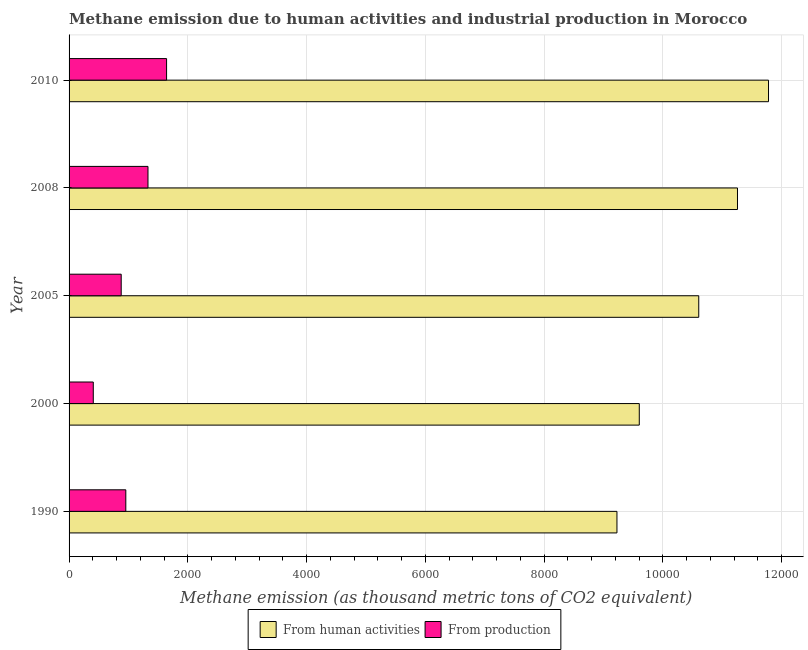How many different coloured bars are there?
Provide a succinct answer. 2. Are the number of bars on each tick of the Y-axis equal?
Ensure brevity in your answer.  Yes. What is the label of the 5th group of bars from the top?
Provide a succinct answer. 1990. In how many cases, is the number of bars for a given year not equal to the number of legend labels?
Ensure brevity in your answer.  0. What is the amount of emissions generated from industries in 2008?
Your answer should be very brief. 1328.7. Across all years, what is the maximum amount of emissions from human activities?
Your answer should be compact. 1.18e+04. Across all years, what is the minimum amount of emissions generated from industries?
Ensure brevity in your answer.  407.6. In which year was the amount of emissions generated from industries minimum?
Offer a very short reply. 2000. What is the total amount of emissions generated from industries in the graph?
Your answer should be compact. 5211.3. What is the difference between the amount of emissions generated from industries in 1990 and that in 2005?
Offer a terse response. 77.7. What is the difference between the amount of emissions from human activities in 2005 and the amount of emissions generated from industries in 2008?
Your answer should be compact. 9274.2. What is the average amount of emissions from human activities per year?
Keep it short and to the point. 1.05e+04. In the year 2008, what is the difference between the amount of emissions from human activities and amount of emissions generated from industries?
Provide a succinct answer. 9926.4. What is the ratio of the amount of emissions from human activities in 2005 to that in 2010?
Make the answer very short. 0.9. What is the difference between the highest and the second highest amount of emissions generated from industries?
Offer a terse response. 313.2. What is the difference between the highest and the lowest amount of emissions generated from industries?
Offer a terse response. 1234.3. What does the 1st bar from the top in 2010 represents?
Your answer should be very brief. From production. What does the 2nd bar from the bottom in 2008 represents?
Your response must be concise. From production. Are all the bars in the graph horizontal?
Offer a very short reply. Yes. Does the graph contain grids?
Give a very brief answer. Yes. Where does the legend appear in the graph?
Make the answer very short. Bottom center. How many legend labels are there?
Keep it short and to the point. 2. How are the legend labels stacked?
Your answer should be very brief. Horizontal. What is the title of the graph?
Your response must be concise. Methane emission due to human activities and industrial production in Morocco. Does "Total Population" appear as one of the legend labels in the graph?
Give a very brief answer. No. What is the label or title of the X-axis?
Your response must be concise. Methane emission (as thousand metric tons of CO2 equivalent). What is the Methane emission (as thousand metric tons of CO2 equivalent) in From human activities in 1990?
Offer a terse response. 9225.5. What is the Methane emission (as thousand metric tons of CO2 equivalent) of From production in 1990?
Your response must be concise. 955.4. What is the Methane emission (as thousand metric tons of CO2 equivalent) in From human activities in 2000?
Ensure brevity in your answer.  9601.5. What is the Methane emission (as thousand metric tons of CO2 equivalent) of From production in 2000?
Offer a very short reply. 407.6. What is the Methane emission (as thousand metric tons of CO2 equivalent) in From human activities in 2005?
Offer a terse response. 1.06e+04. What is the Methane emission (as thousand metric tons of CO2 equivalent) of From production in 2005?
Offer a very short reply. 877.7. What is the Methane emission (as thousand metric tons of CO2 equivalent) of From human activities in 2008?
Your response must be concise. 1.13e+04. What is the Methane emission (as thousand metric tons of CO2 equivalent) in From production in 2008?
Offer a terse response. 1328.7. What is the Methane emission (as thousand metric tons of CO2 equivalent) of From human activities in 2010?
Provide a succinct answer. 1.18e+04. What is the Methane emission (as thousand metric tons of CO2 equivalent) of From production in 2010?
Offer a very short reply. 1641.9. Across all years, what is the maximum Methane emission (as thousand metric tons of CO2 equivalent) in From human activities?
Ensure brevity in your answer.  1.18e+04. Across all years, what is the maximum Methane emission (as thousand metric tons of CO2 equivalent) of From production?
Ensure brevity in your answer.  1641.9. Across all years, what is the minimum Methane emission (as thousand metric tons of CO2 equivalent) of From human activities?
Provide a succinct answer. 9225.5. Across all years, what is the minimum Methane emission (as thousand metric tons of CO2 equivalent) in From production?
Give a very brief answer. 407.6. What is the total Methane emission (as thousand metric tons of CO2 equivalent) of From human activities in the graph?
Offer a very short reply. 5.25e+04. What is the total Methane emission (as thousand metric tons of CO2 equivalent) in From production in the graph?
Provide a short and direct response. 5211.3. What is the difference between the Methane emission (as thousand metric tons of CO2 equivalent) in From human activities in 1990 and that in 2000?
Ensure brevity in your answer.  -376. What is the difference between the Methane emission (as thousand metric tons of CO2 equivalent) of From production in 1990 and that in 2000?
Your answer should be compact. 547.8. What is the difference between the Methane emission (as thousand metric tons of CO2 equivalent) in From human activities in 1990 and that in 2005?
Keep it short and to the point. -1377.4. What is the difference between the Methane emission (as thousand metric tons of CO2 equivalent) of From production in 1990 and that in 2005?
Give a very brief answer. 77.7. What is the difference between the Methane emission (as thousand metric tons of CO2 equivalent) in From human activities in 1990 and that in 2008?
Your answer should be compact. -2029.6. What is the difference between the Methane emission (as thousand metric tons of CO2 equivalent) in From production in 1990 and that in 2008?
Keep it short and to the point. -373.3. What is the difference between the Methane emission (as thousand metric tons of CO2 equivalent) of From human activities in 1990 and that in 2010?
Keep it short and to the point. -2552.1. What is the difference between the Methane emission (as thousand metric tons of CO2 equivalent) in From production in 1990 and that in 2010?
Your answer should be very brief. -686.5. What is the difference between the Methane emission (as thousand metric tons of CO2 equivalent) in From human activities in 2000 and that in 2005?
Ensure brevity in your answer.  -1001.4. What is the difference between the Methane emission (as thousand metric tons of CO2 equivalent) in From production in 2000 and that in 2005?
Give a very brief answer. -470.1. What is the difference between the Methane emission (as thousand metric tons of CO2 equivalent) in From human activities in 2000 and that in 2008?
Your response must be concise. -1653.6. What is the difference between the Methane emission (as thousand metric tons of CO2 equivalent) in From production in 2000 and that in 2008?
Your answer should be compact. -921.1. What is the difference between the Methane emission (as thousand metric tons of CO2 equivalent) of From human activities in 2000 and that in 2010?
Give a very brief answer. -2176.1. What is the difference between the Methane emission (as thousand metric tons of CO2 equivalent) of From production in 2000 and that in 2010?
Give a very brief answer. -1234.3. What is the difference between the Methane emission (as thousand metric tons of CO2 equivalent) of From human activities in 2005 and that in 2008?
Your answer should be very brief. -652.2. What is the difference between the Methane emission (as thousand metric tons of CO2 equivalent) of From production in 2005 and that in 2008?
Keep it short and to the point. -451. What is the difference between the Methane emission (as thousand metric tons of CO2 equivalent) of From human activities in 2005 and that in 2010?
Offer a terse response. -1174.7. What is the difference between the Methane emission (as thousand metric tons of CO2 equivalent) of From production in 2005 and that in 2010?
Provide a succinct answer. -764.2. What is the difference between the Methane emission (as thousand metric tons of CO2 equivalent) of From human activities in 2008 and that in 2010?
Offer a very short reply. -522.5. What is the difference between the Methane emission (as thousand metric tons of CO2 equivalent) of From production in 2008 and that in 2010?
Ensure brevity in your answer.  -313.2. What is the difference between the Methane emission (as thousand metric tons of CO2 equivalent) of From human activities in 1990 and the Methane emission (as thousand metric tons of CO2 equivalent) of From production in 2000?
Ensure brevity in your answer.  8817.9. What is the difference between the Methane emission (as thousand metric tons of CO2 equivalent) in From human activities in 1990 and the Methane emission (as thousand metric tons of CO2 equivalent) in From production in 2005?
Your answer should be compact. 8347.8. What is the difference between the Methane emission (as thousand metric tons of CO2 equivalent) of From human activities in 1990 and the Methane emission (as thousand metric tons of CO2 equivalent) of From production in 2008?
Your response must be concise. 7896.8. What is the difference between the Methane emission (as thousand metric tons of CO2 equivalent) of From human activities in 1990 and the Methane emission (as thousand metric tons of CO2 equivalent) of From production in 2010?
Your response must be concise. 7583.6. What is the difference between the Methane emission (as thousand metric tons of CO2 equivalent) of From human activities in 2000 and the Methane emission (as thousand metric tons of CO2 equivalent) of From production in 2005?
Give a very brief answer. 8723.8. What is the difference between the Methane emission (as thousand metric tons of CO2 equivalent) in From human activities in 2000 and the Methane emission (as thousand metric tons of CO2 equivalent) in From production in 2008?
Provide a short and direct response. 8272.8. What is the difference between the Methane emission (as thousand metric tons of CO2 equivalent) in From human activities in 2000 and the Methane emission (as thousand metric tons of CO2 equivalent) in From production in 2010?
Give a very brief answer. 7959.6. What is the difference between the Methane emission (as thousand metric tons of CO2 equivalent) in From human activities in 2005 and the Methane emission (as thousand metric tons of CO2 equivalent) in From production in 2008?
Keep it short and to the point. 9274.2. What is the difference between the Methane emission (as thousand metric tons of CO2 equivalent) of From human activities in 2005 and the Methane emission (as thousand metric tons of CO2 equivalent) of From production in 2010?
Your answer should be very brief. 8961. What is the difference between the Methane emission (as thousand metric tons of CO2 equivalent) in From human activities in 2008 and the Methane emission (as thousand metric tons of CO2 equivalent) in From production in 2010?
Your response must be concise. 9613.2. What is the average Methane emission (as thousand metric tons of CO2 equivalent) in From human activities per year?
Provide a succinct answer. 1.05e+04. What is the average Methane emission (as thousand metric tons of CO2 equivalent) in From production per year?
Make the answer very short. 1042.26. In the year 1990, what is the difference between the Methane emission (as thousand metric tons of CO2 equivalent) in From human activities and Methane emission (as thousand metric tons of CO2 equivalent) in From production?
Make the answer very short. 8270.1. In the year 2000, what is the difference between the Methane emission (as thousand metric tons of CO2 equivalent) in From human activities and Methane emission (as thousand metric tons of CO2 equivalent) in From production?
Ensure brevity in your answer.  9193.9. In the year 2005, what is the difference between the Methane emission (as thousand metric tons of CO2 equivalent) in From human activities and Methane emission (as thousand metric tons of CO2 equivalent) in From production?
Keep it short and to the point. 9725.2. In the year 2008, what is the difference between the Methane emission (as thousand metric tons of CO2 equivalent) in From human activities and Methane emission (as thousand metric tons of CO2 equivalent) in From production?
Give a very brief answer. 9926.4. In the year 2010, what is the difference between the Methane emission (as thousand metric tons of CO2 equivalent) of From human activities and Methane emission (as thousand metric tons of CO2 equivalent) of From production?
Provide a succinct answer. 1.01e+04. What is the ratio of the Methane emission (as thousand metric tons of CO2 equivalent) in From human activities in 1990 to that in 2000?
Your response must be concise. 0.96. What is the ratio of the Methane emission (as thousand metric tons of CO2 equivalent) of From production in 1990 to that in 2000?
Your answer should be compact. 2.34. What is the ratio of the Methane emission (as thousand metric tons of CO2 equivalent) in From human activities in 1990 to that in 2005?
Offer a terse response. 0.87. What is the ratio of the Methane emission (as thousand metric tons of CO2 equivalent) of From production in 1990 to that in 2005?
Offer a very short reply. 1.09. What is the ratio of the Methane emission (as thousand metric tons of CO2 equivalent) in From human activities in 1990 to that in 2008?
Your answer should be compact. 0.82. What is the ratio of the Methane emission (as thousand metric tons of CO2 equivalent) of From production in 1990 to that in 2008?
Offer a very short reply. 0.72. What is the ratio of the Methane emission (as thousand metric tons of CO2 equivalent) of From human activities in 1990 to that in 2010?
Your answer should be very brief. 0.78. What is the ratio of the Methane emission (as thousand metric tons of CO2 equivalent) of From production in 1990 to that in 2010?
Offer a very short reply. 0.58. What is the ratio of the Methane emission (as thousand metric tons of CO2 equivalent) in From human activities in 2000 to that in 2005?
Ensure brevity in your answer.  0.91. What is the ratio of the Methane emission (as thousand metric tons of CO2 equivalent) in From production in 2000 to that in 2005?
Your response must be concise. 0.46. What is the ratio of the Methane emission (as thousand metric tons of CO2 equivalent) of From human activities in 2000 to that in 2008?
Your answer should be very brief. 0.85. What is the ratio of the Methane emission (as thousand metric tons of CO2 equivalent) of From production in 2000 to that in 2008?
Keep it short and to the point. 0.31. What is the ratio of the Methane emission (as thousand metric tons of CO2 equivalent) of From human activities in 2000 to that in 2010?
Your answer should be very brief. 0.82. What is the ratio of the Methane emission (as thousand metric tons of CO2 equivalent) in From production in 2000 to that in 2010?
Offer a very short reply. 0.25. What is the ratio of the Methane emission (as thousand metric tons of CO2 equivalent) in From human activities in 2005 to that in 2008?
Keep it short and to the point. 0.94. What is the ratio of the Methane emission (as thousand metric tons of CO2 equivalent) of From production in 2005 to that in 2008?
Your response must be concise. 0.66. What is the ratio of the Methane emission (as thousand metric tons of CO2 equivalent) in From human activities in 2005 to that in 2010?
Your response must be concise. 0.9. What is the ratio of the Methane emission (as thousand metric tons of CO2 equivalent) in From production in 2005 to that in 2010?
Your answer should be compact. 0.53. What is the ratio of the Methane emission (as thousand metric tons of CO2 equivalent) of From human activities in 2008 to that in 2010?
Provide a succinct answer. 0.96. What is the ratio of the Methane emission (as thousand metric tons of CO2 equivalent) in From production in 2008 to that in 2010?
Provide a short and direct response. 0.81. What is the difference between the highest and the second highest Methane emission (as thousand metric tons of CO2 equivalent) of From human activities?
Provide a short and direct response. 522.5. What is the difference between the highest and the second highest Methane emission (as thousand metric tons of CO2 equivalent) of From production?
Keep it short and to the point. 313.2. What is the difference between the highest and the lowest Methane emission (as thousand metric tons of CO2 equivalent) in From human activities?
Provide a succinct answer. 2552.1. What is the difference between the highest and the lowest Methane emission (as thousand metric tons of CO2 equivalent) in From production?
Keep it short and to the point. 1234.3. 